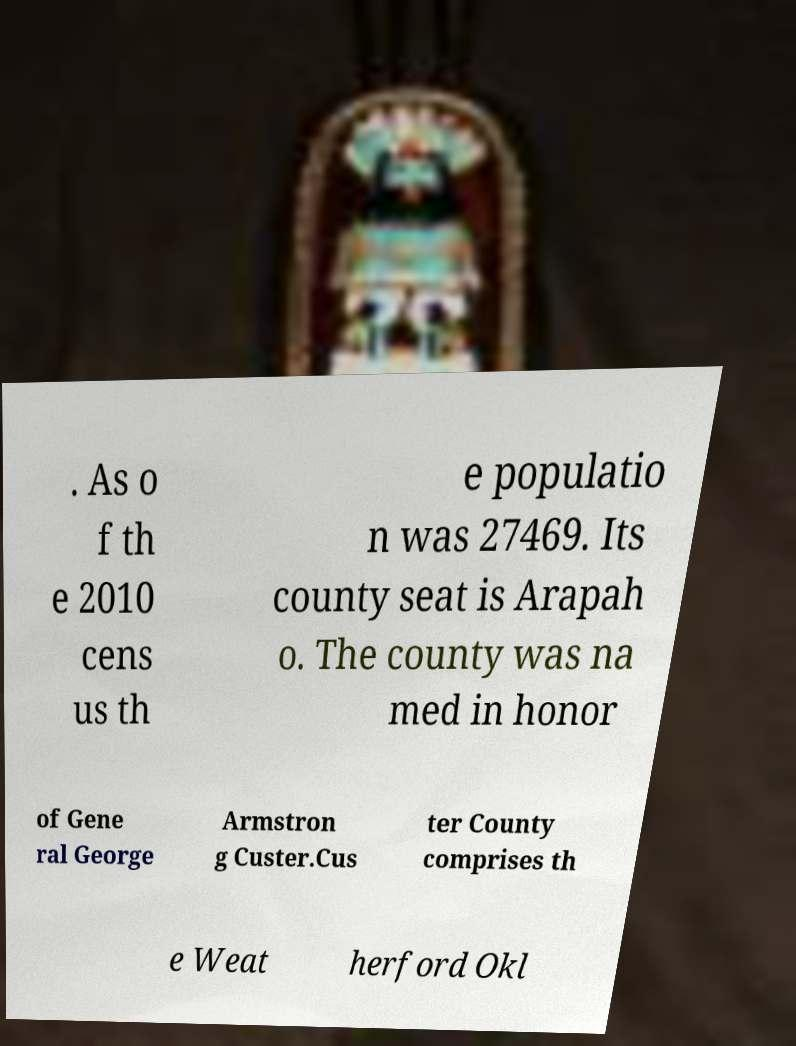Could you assist in decoding the text presented in this image and type it out clearly? . As o f th e 2010 cens us th e populatio n was 27469. Its county seat is Arapah o. The county was na med in honor of Gene ral George Armstron g Custer.Cus ter County comprises th e Weat herford Okl 